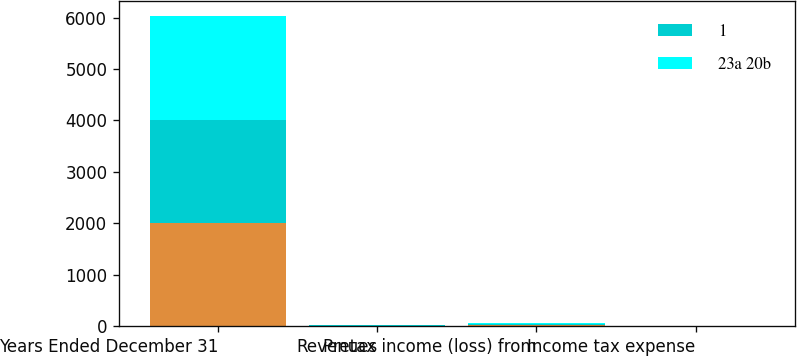Convert chart to OTSL. <chart><loc_0><loc_0><loc_500><loc_500><stacked_bar_chart><ecel><fcel>Years Ended December 31<fcel>Revenues<fcel>Pretax income (loss) from<fcel>Income tax expense<nl><fcel>nan<fcel>2010<fcel>10<fcel>21<fcel>2<nl><fcel>1<fcel>2009<fcel>7<fcel>33<fcel>13<nl><fcel>23a 20b<fcel>2008<fcel>14<fcel>2<fcel>1<nl></chart> 